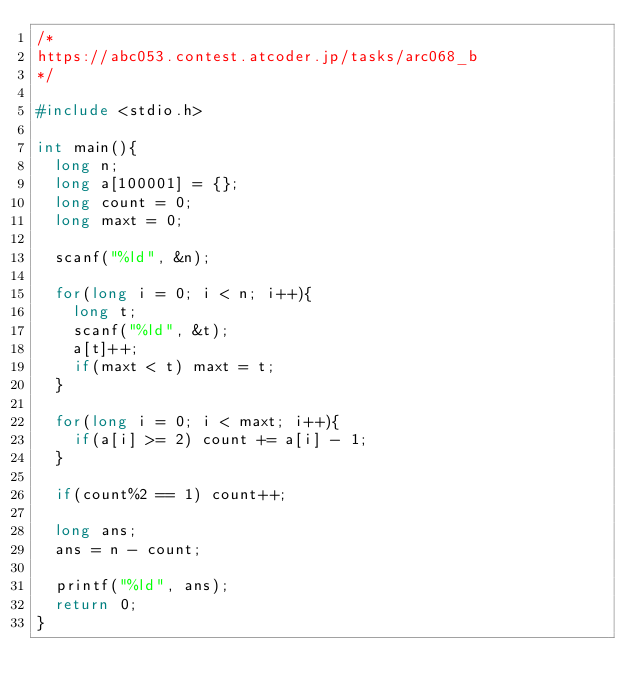<code> <loc_0><loc_0><loc_500><loc_500><_C_>/*
https://abc053.contest.atcoder.jp/tasks/arc068_b
*/

#include <stdio.h>

int main(){
  long n;
  long a[100001] = {};
  long count = 0;
  long maxt = 0;

  scanf("%ld", &n);

  for(long i = 0; i < n; i++){
    long t;
    scanf("%ld", &t);
    a[t]++;
    if(maxt < t) maxt = t;
  }

  for(long i = 0; i < maxt; i++){
    if(a[i] >= 2) count += a[i] - 1;
  }

  if(count%2 == 1) count++;

  long ans;
  ans = n - count;

  printf("%ld", ans);
  return 0;
}
</code> 